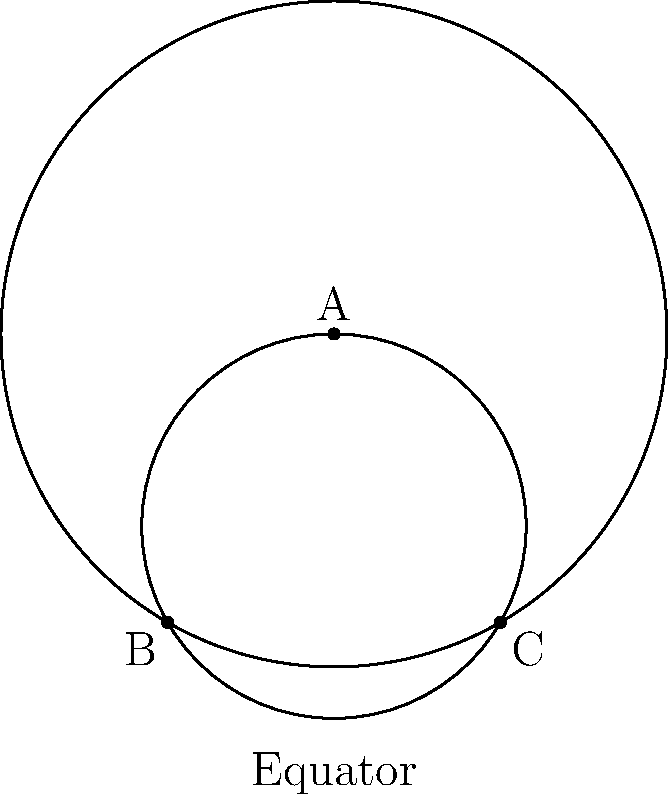In the context of diverging audience interests on social media platforms, consider the spherical geometry model shown above. If lines AB and AC represent two initially parallel content strategies, what happens to these "parallel lines" as they extend from point A towards the equator? To understand this concept, let's break it down step-by-step:

1. In spherical geometry, the surface of a sphere represents our "plane."

2. "Straight lines" on a sphere are actually great circles, which are the largest possible circles that can be drawn on the sphere's surface.

3. In the diagram, lines AB and AC are arcs of great circles starting from point A (which could represent the initial content strategy).

4. These lines start parallel at A (representing similar content), but as they extend towards the equator:

   a) They begin to diverge from each other.
   b) They will eventually intersect at a point opposite to A on the sphere (not shown in this 2D representation).

5. This divergence is analogous to how initially similar content strategies might evolve differently over time, appealing to different audience segments.

6. The equator in this model could represent the broad spectrum of potential audience interests.

7. As the lines approach the equator, they are maximally separated, symbolizing how content strategies might become distinctly different to cater to diverse audience preferences.

This geometric model illustrates how parallel strategies in social media content creation may naturally diverge to capture different audience segments, even if they start from the same point.
Answer: The parallel lines diverge and eventually intersect. 